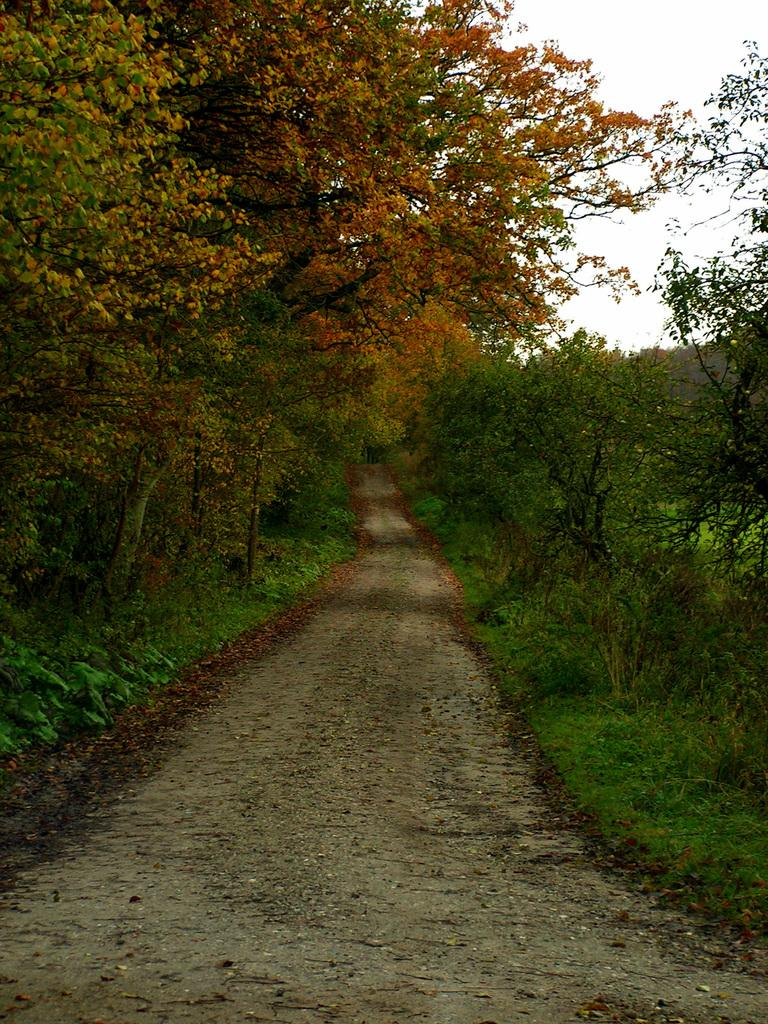What type of view is shown in the image? The image is an outside view. What is located at the bottom of the image? There is a road at the bottom of the image. What can be seen on both sides of the road? Plants and trees are visible on both sides of the road. What is visible at the top of the image? The sky is visible at the top of the image. What color is the zipper on the tree in the image? There is no zipper present on the tree or any other object in the image. 